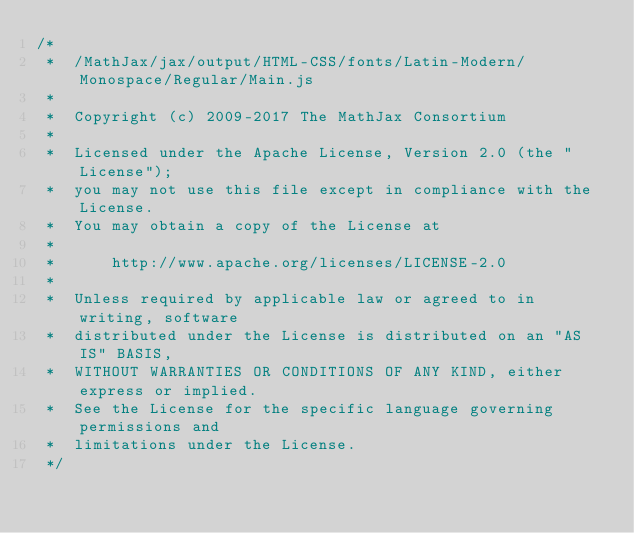Convert code to text. <code><loc_0><loc_0><loc_500><loc_500><_JavaScript_>/*
 *  /MathJax/jax/output/HTML-CSS/fonts/Latin-Modern/Monospace/Regular/Main.js
 *
 *  Copyright (c) 2009-2017 The MathJax Consortium
 *
 *  Licensed under the Apache License, Version 2.0 (the "License");
 *  you may not use this file except in compliance with the License.
 *  You may obtain a copy of the License at
 *
 *      http://www.apache.org/licenses/LICENSE-2.0
 *
 *  Unless required by applicable law or agreed to in writing, software
 *  distributed under the License is distributed on an "AS IS" BASIS,
 *  WITHOUT WARRANTIES OR CONDITIONS OF ANY KIND, either express or implied.
 *  See the License for the specific language governing permissions and
 *  limitations under the License.
 */
</code> 